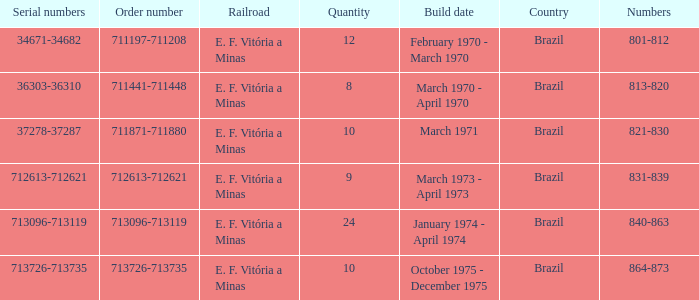How many railroads have the numbers 864-873? 1.0. 